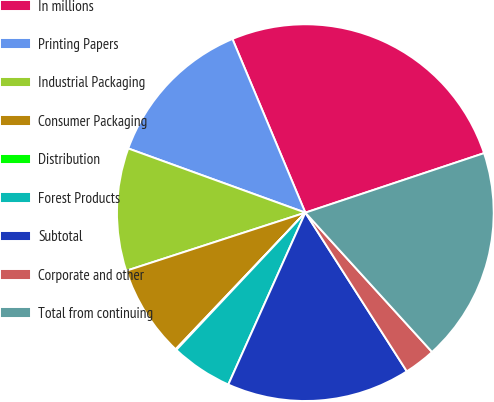Convert chart. <chart><loc_0><loc_0><loc_500><loc_500><pie_chart><fcel>In millions<fcel>Printing Papers<fcel>Industrial Packaging<fcel>Consumer Packaging<fcel>Distribution<fcel>Forest Products<fcel>Subtotal<fcel>Corporate and other<fcel>Total from continuing<nl><fcel>26.21%<fcel>13.14%<fcel>10.53%<fcel>7.92%<fcel>0.08%<fcel>5.3%<fcel>15.76%<fcel>2.69%<fcel>18.37%<nl></chart> 